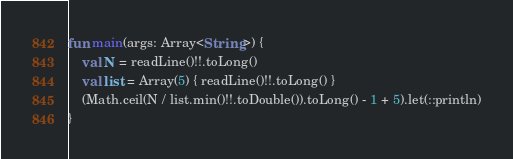<code> <loc_0><loc_0><loc_500><loc_500><_Kotlin_>fun main(args: Array<String>) {
    val N = readLine()!!.toLong()
    val list = Array(5) { readLine()!!.toLong() }
    (Math.ceil(N / list.min()!!.toDouble()).toLong() - 1 + 5).let(::println)
}

</code> 